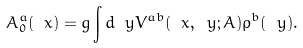Convert formula to latex. <formula><loc_0><loc_0><loc_500><loc_500>A ^ { a } _ { 0 } ( \ x ) = g \int d \ y V ^ { a b } ( \ x , \ y ; A ) \rho ^ { b } ( \ y ) .</formula> 